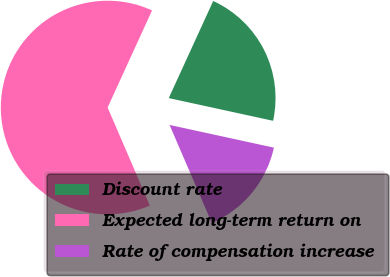<chart> <loc_0><loc_0><loc_500><loc_500><pie_chart><fcel>Discount rate<fcel>Expected long-term return on<fcel>Rate of compensation increase<nl><fcel>21.58%<fcel>63.31%<fcel>15.11%<nl></chart> 